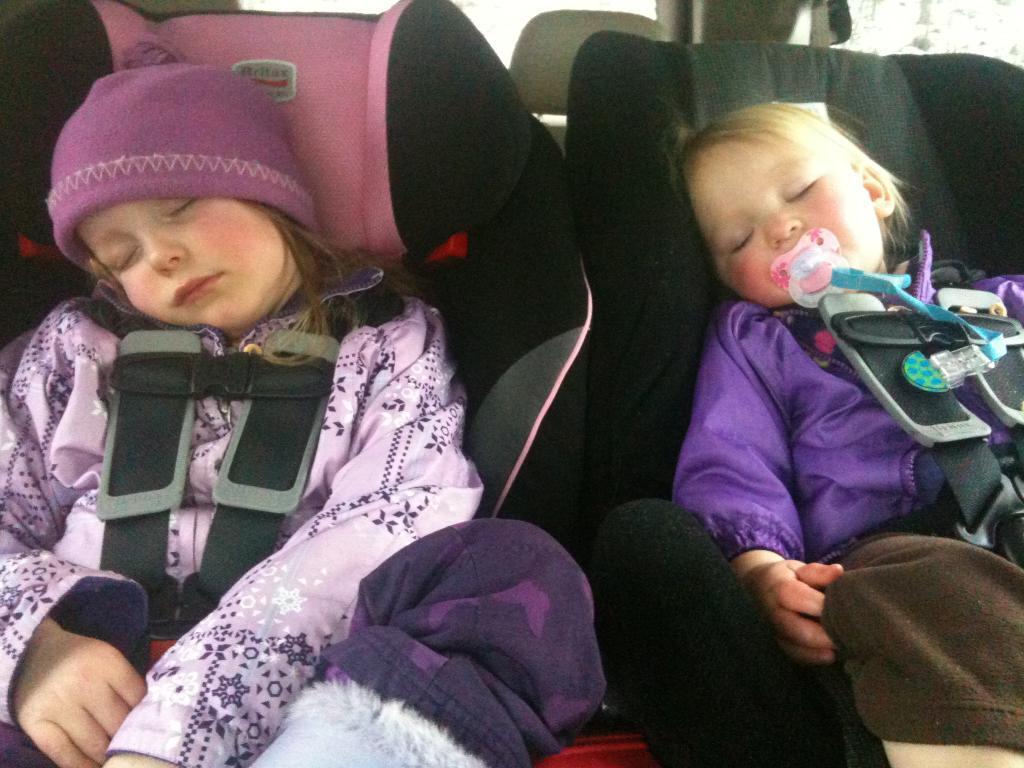Can you describe this image briefly? In this image I can see two persons sleeping, the person at right is wearing purple and brown color dress and the person at left is wearing purple color dress. 